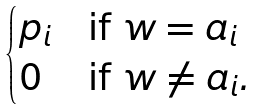Convert formula to latex. <formula><loc_0><loc_0><loc_500><loc_500>\begin{cases} p _ { i } & \text {if $w = a_{i}$ } \\ 0 & \text {if $w \neq a_{i}$} . \end{cases}</formula> 